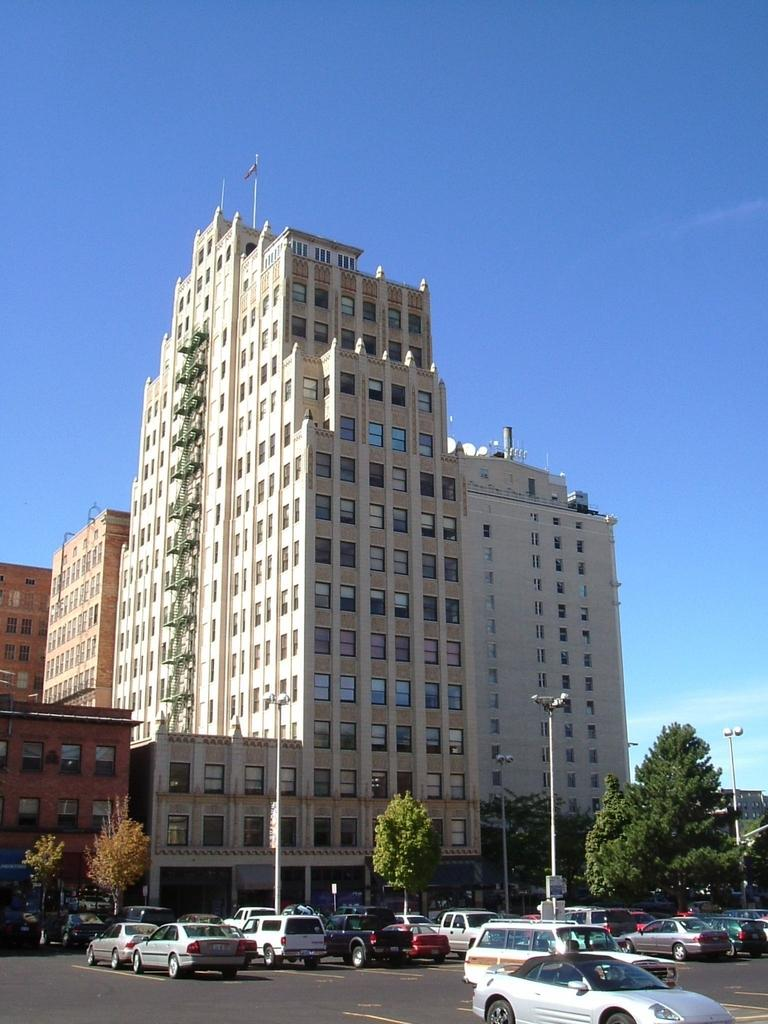What can be seen on the road in the image? There are vehicles on the road in the image. What is located behind the vehicles? There are trees behind the vehicles. What structures are present in the image with lights? There are poles with lights in the image. What is visible behind the poles with lights? There are buildings behind the poles. What part of the natural environment can be seen in the image? The sky is visible in the image. Can you tell me about the history of the vein in the image? There is no vein present in the image, and therefore no history to discuss. Who is the aunt in the image? There is no aunt present in the image. 